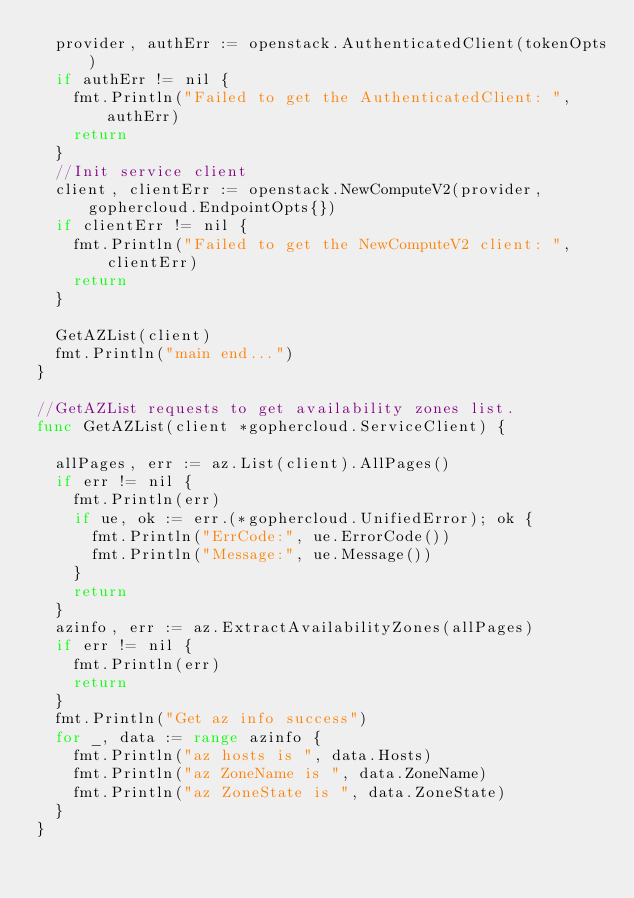<code> <loc_0><loc_0><loc_500><loc_500><_Go_>	provider, authErr := openstack.AuthenticatedClient(tokenOpts)
	if authErr != nil {
		fmt.Println("Failed to get the AuthenticatedClient: ", authErr)
		return
	}
	//Init service client
	client, clientErr := openstack.NewComputeV2(provider, gophercloud.EndpointOpts{})
	if clientErr != nil {
		fmt.Println("Failed to get the NewComputeV2 client: ", clientErr)
		return
	}

	GetAZList(client)
	fmt.Println("main end...")
}

//GetAZList requests to get availability zones list.
func GetAZList(client *gophercloud.ServiceClient) {

	allPages, err := az.List(client).AllPages()
	if err != nil {
		fmt.Println(err)
		if ue, ok := err.(*gophercloud.UnifiedError); ok {
			fmt.Println("ErrCode:", ue.ErrorCode())
			fmt.Println("Message:", ue.Message())
		}
		return
	}
	azinfo, err := az.ExtractAvailabilityZones(allPages)
	if err != nil {
		fmt.Println(err)
		return
	}
	fmt.Println("Get az info success")
	for _, data := range azinfo {
		fmt.Println("az hosts is ", data.Hosts)
		fmt.Println("az ZoneName is ", data.ZoneName)
		fmt.Println("az ZoneState is ", data.ZoneState)
	}
}</code> 